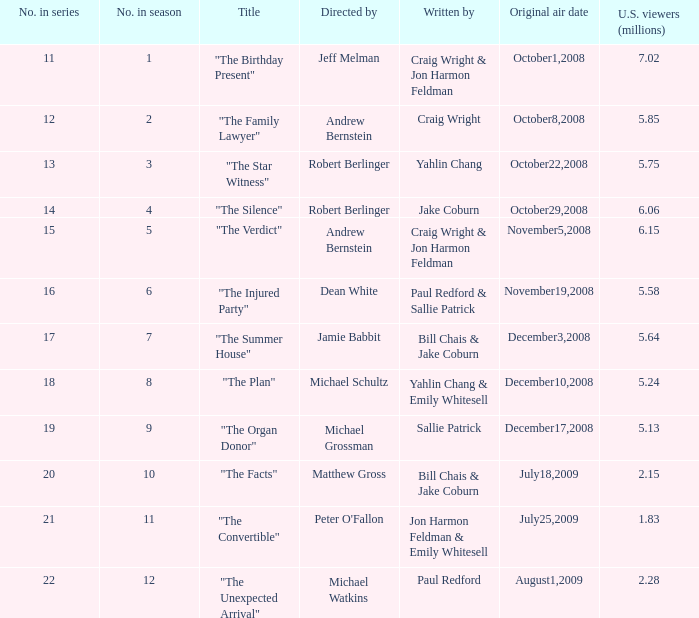What number episode in the season is "The Family Lawyer"? 2.0. Parse the table in full. {'header': ['No. in series', 'No. in season', 'Title', 'Directed by', 'Written by', 'Original air date', 'U.S. viewers (millions)'], 'rows': [['11', '1', '"The Birthday Present"', 'Jeff Melman', 'Craig Wright & Jon Harmon Feldman', 'October1,2008', '7.02'], ['12', '2', '"The Family Lawyer"', 'Andrew Bernstein', 'Craig Wright', 'October8,2008', '5.85'], ['13', '3', '"The Star Witness"', 'Robert Berlinger', 'Yahlin Chang', 'October22,2008', '5.75'], ['14', '4', '"The Silence"', 'Robert Berlinger', 'Jake Coburn', 'October29,2008', '6.06'], ['15', '5', '"The Verdict"', 'Andrew Bernstein', 'Craig Wright & Jon Harmon Feldman', 'November5,2008', '6.15'], ['16', '6', '"The Injured Party"', 'Dean White', 'Paul Redford & Sallie Patrick', 'November19,2008', '5.58'], ['17', '7', '"The Summer House"', 'Jamie Babbit', 'Bill Chais & Jake Coburn', 'December3,2008', '5.64'], ['18', '8', '"The Plan"', 'Michael Schultz', 'Yahlin Chang & Emily Whitesell', 'December10,2008', '5.24'], ['19', '9', '"The Organ Donor"', 'Michael Grossman', 'Sallie Patrick', 'December17,2008', '5.13'], ['20', '10', '"The Facts"', 'Matthew Gross', 'Bill Chais & Jake Coburn', 'July18,2009', '2.15'], ['21', '11', '"The Convertible"', "Peter O'Fallon", 'Jon Harmon Feldman & Emily Whitesell', 'July25,2009', '1.83'], ['22', '12', '"The Unexpected Arrival"', 'Michael Watkins', 'Paul Redford', 'August1,2009', '2.28']]} 